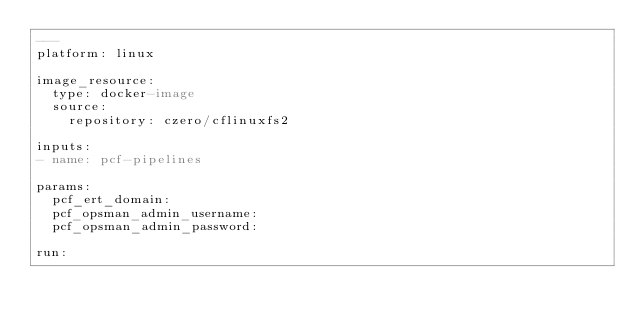Convert code to text. <code><loc_0><loc_0><loc_500><loc_500><_YAML_>---
platform: linux

image_resource:
  type: docker-image
  source:
    repository: czero/cflinuxfs2

inputs:
- name: pcf-pipelines 

params:
  pcf_ert_domain:
  pcf_opsman_admin_username:
  pcf_opsman_admin_password:

run:</code> 